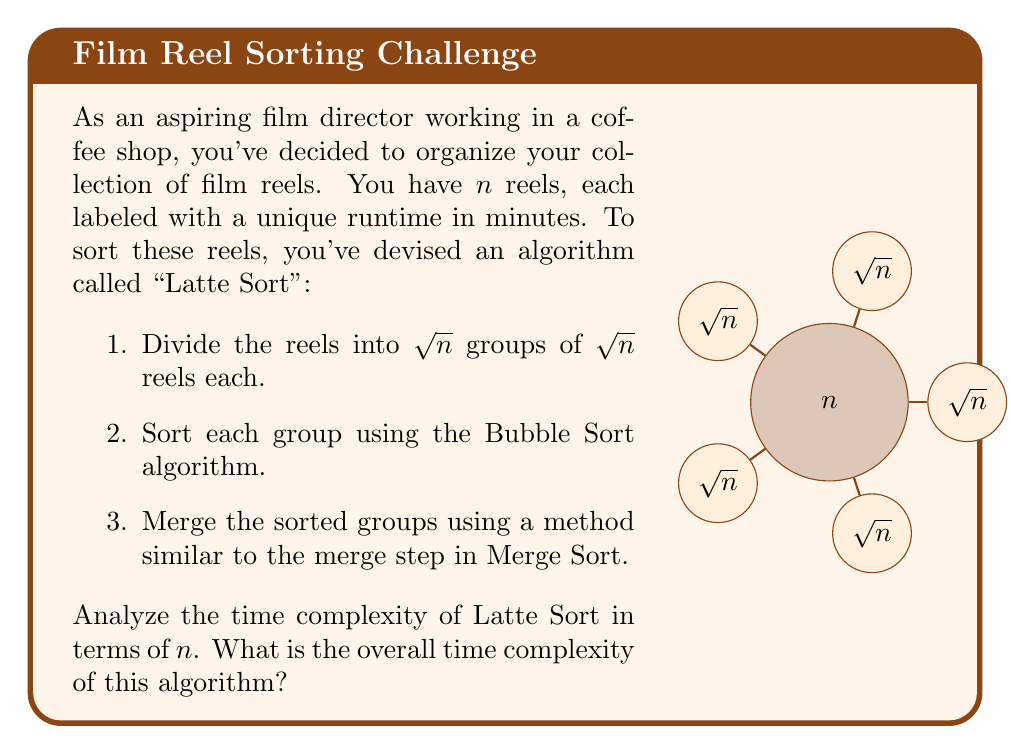Could you help me with this problem? Let's analyze the time complexity of Latte Sort step by step:

1. Dividing the reels:
   - This step takes $O(n)$ time as we need to go through all $n$ reels once.

2. Sorting each group using Bubble Sort:
   - We have $\sqrt{n}$ groups, each containing $\sqrt{n}$ reels.
   - Bubble Sort has a time complexity of $O(m^2)$ for $m$ elements.
   - For each group: $O((\sqrt{n})^2) = O(n)$
   - Total for all groups: $O(n) \times \sqrt{n} = O(n^{3/2})$

3. Merging the sorted groups:
   - Similar to the merge step in Merge Sort, but with $\sqrt{n}$ groups instead of 2.
   - We need to compare and place each of the $n$ elements.
   - At each step, we're comparing up to $\sqrt{n}$ elements (one from each group).
   - Total comparisons: $O(n \log \sqrt{n}) = O(n \log n)$

Now, we sum up the time complexities of each step:
$$O(n) + O(n^{3/2}) + O(n \log n)$$

The dominant term in this sum is $O(n^{3/2})$, as it grows faster than both $O(n)$ and $O(n \log n)$ for large values of $n$.

Therefore, the overall time complexity of Latte Sort is $O(n^{3/2})$.
Answer: $O(n^{3/2})$ 